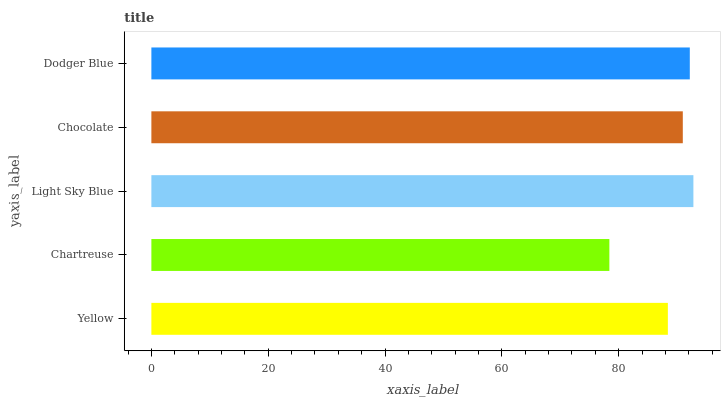Is Chartreuse the minimum?
Answer yes or no. Yes. Is Light Sky Blue the maximum?
Answer yes or no. Yes. Is Light Sky Blue the minimum?
Answer yes or no. No. Is Chartreuse the maximum?
Answer yes or no. No. Is Light Sky Blue greater than Chartreuse?
Answer yes or no. Yes. Is Chartreuse less than Light Sky Blue?
Answer yes or no. Yes. Is Chartreuse greater than Light Sky Blue?
Answer yes or no. No. Is Light Sky Blue less than Chartreuse?
Answer yes or no. No. Is Chocolate the high median?
Answer yes or no. Yes. Is Chocolate the low median?
Answer yes or no. Yes. Is Dodger Blue the high median?
Answer yes or no. No. Is Chartreuse the low median?
Answer yes or no. No. 